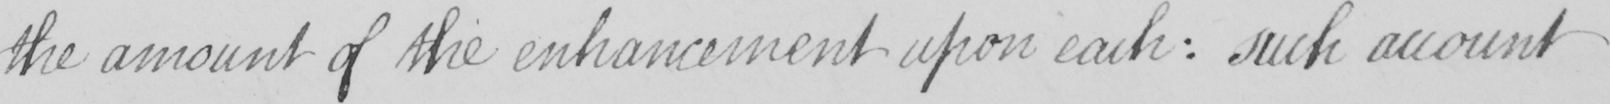Can you read and transcribe this handwriting? the amount of the enhancement upon each :  such account 